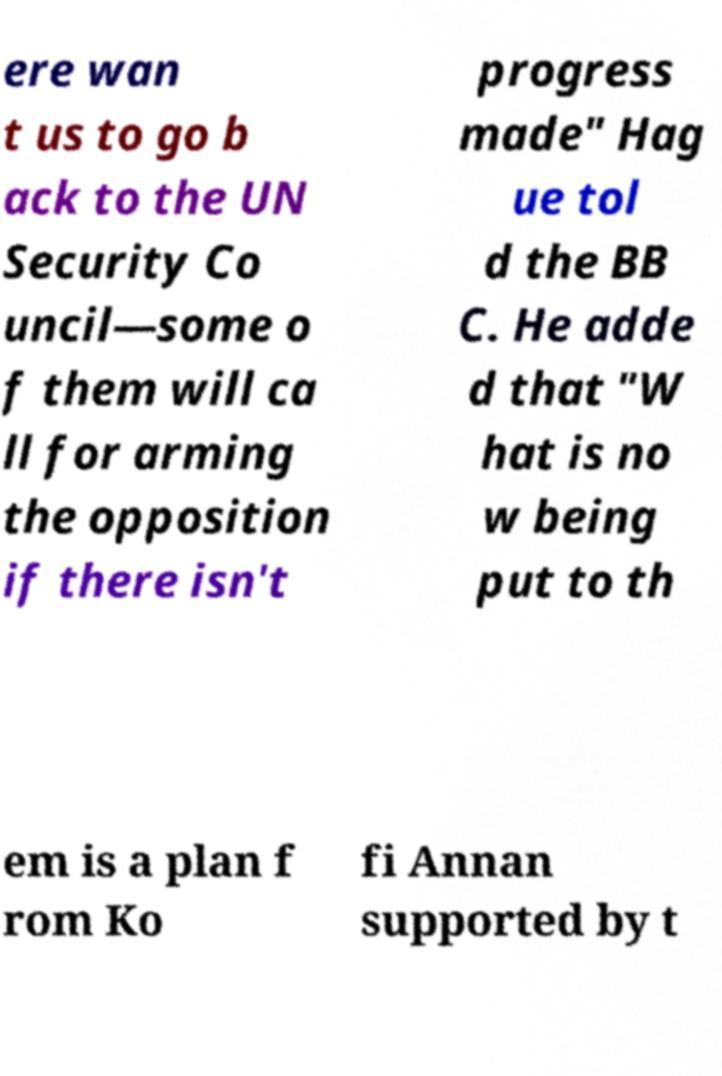For documentation purposes, I need the text within this image transcribed. Could you provide that? ere wan t us to go b ack to the UN Security Co uncil—some o f them will ca ll for arming the opposition if there isn't progress made" Hag ue tol d the BB C. He adde d that "W hat is no w being put to th em is a plan f rom Ko fi Annan supported by t 